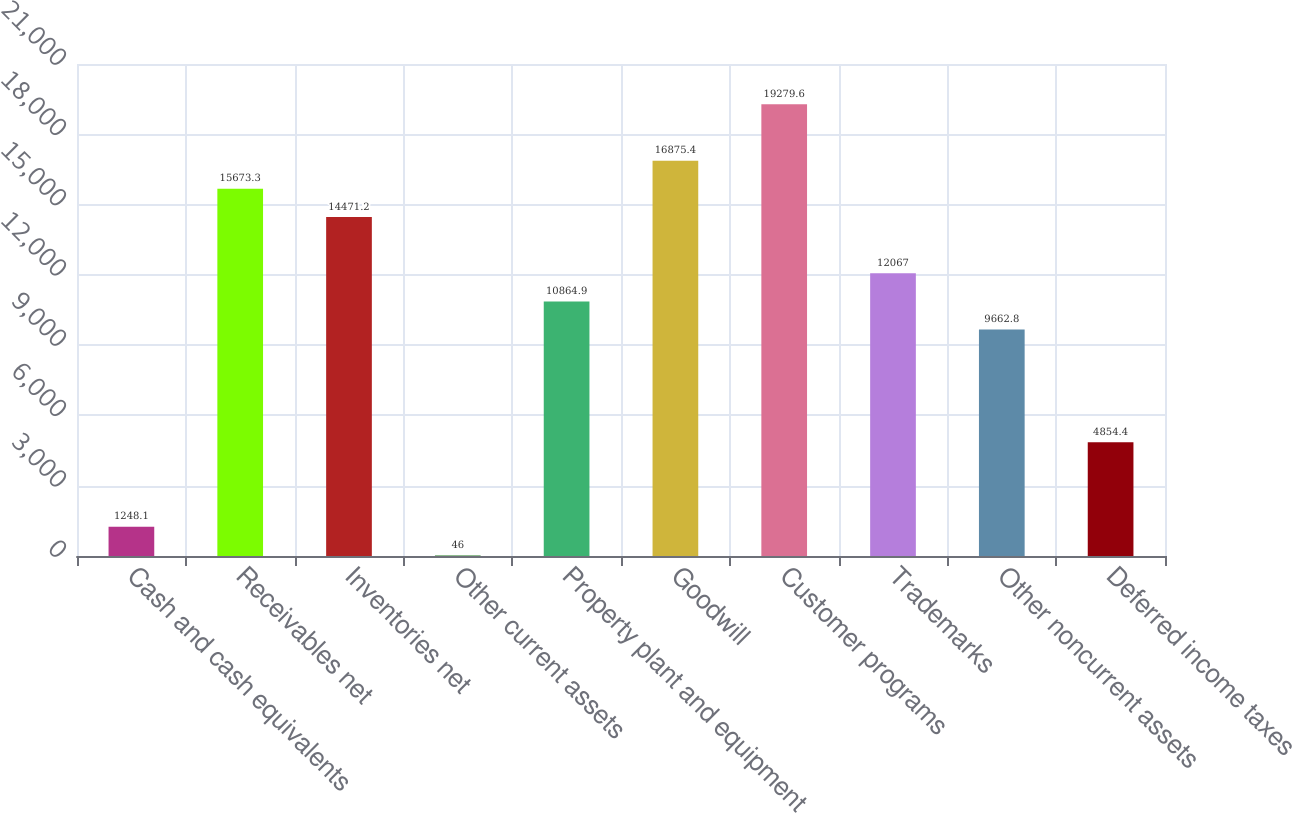Convert chart. <chart><loc_0><loc_0><loc_500><loc_500><bar_chart><fcel>Cash and cash equivalents<fcel>Receivables net<fcel>Inventories net<fcel>Other current assets<fcel>Property plant and equipment<fcel>Goodwill<fcel>Customer programs<fcel>Trademarks<fcel>Other noncurrent assets<fcel>Deferred income taxes<nl><fcel>1248.1<fcel>15673.3<fcel>14471.2<fcel>46<fcel>10864.9<fcel>16875.4<fcel>19279.6<fcel>12067<fcel>9662.8<fcel>4854.4<nl></chart> 